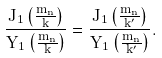Convert formula to latex. <formula><loc_0><loc_0><loc_500><loc_500>\frac { J _ { 1 } \left ( \frac { m _ { n } } { k } \right ) } { Y _ { 1 } \left ( \frac { m _ { n } } { k } \right ) } = \frac { J _ { 1 } \left ( \frac { m _ { n } } { k ^ { \prime } } \right ) } { Y _ { 1 } \left ( \frac { m _ { n } } { k ^ { \prime } } \right ) } .</formula> 